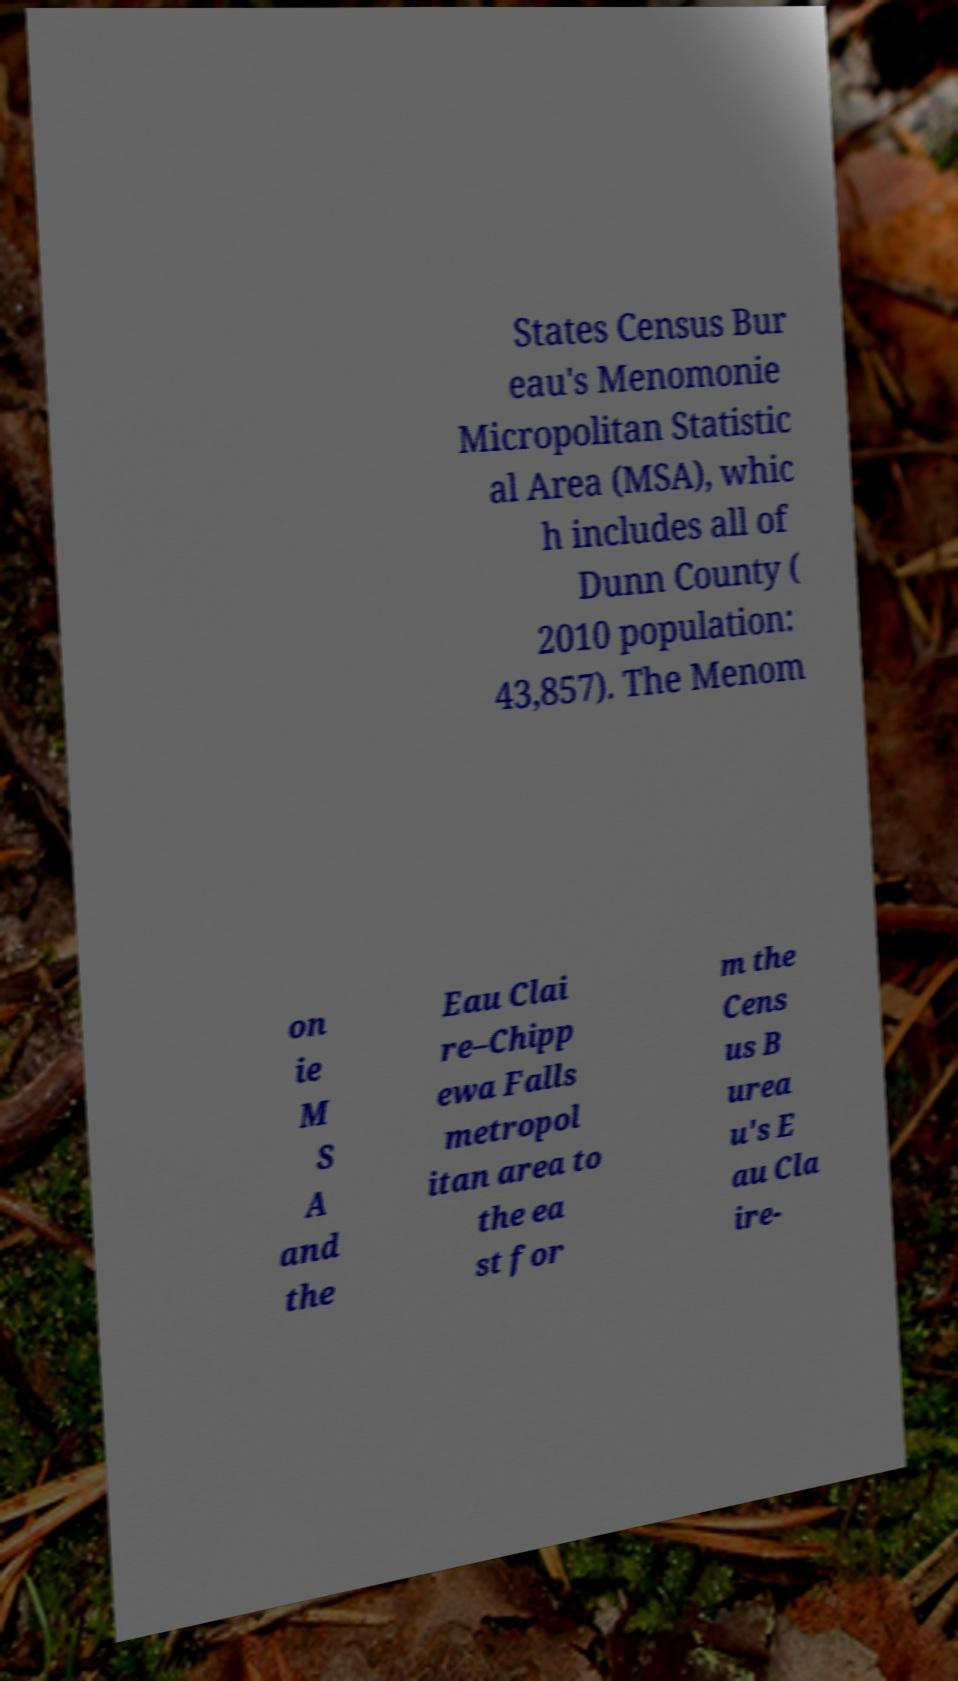Please identify and transcribe the text found in this image. States Census Bur eau's Menomonie Micropolitan Statistic al Area (MSA), whic h includes all of Dunn County ( 2010 population: 43,857). The Menom on ie M S A and the Eau Clai re–Chipp ewa Falls metropol itan area to the ea st for m the Cens us B urea u's E au Cla ire- 